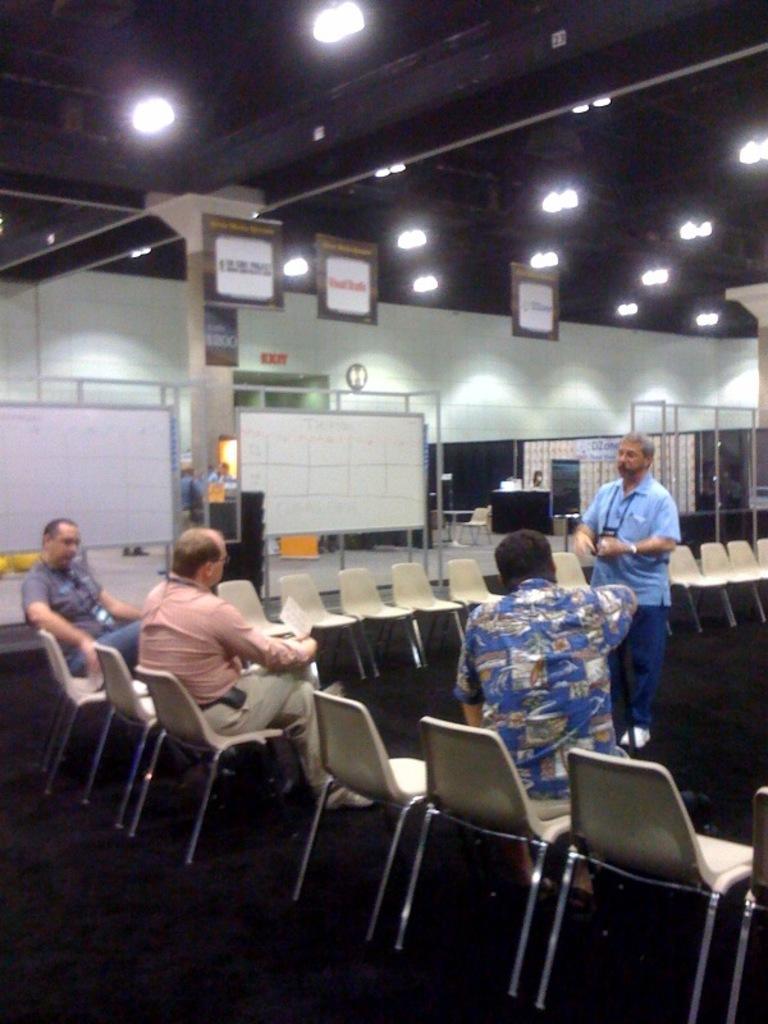Could you give a brief overview of what you see in this image? This image I can see 3 persons sitting on chairs and a person standing behind them, in the background I can see few boards, few lights, the ceiling, a pillar and the wall. 